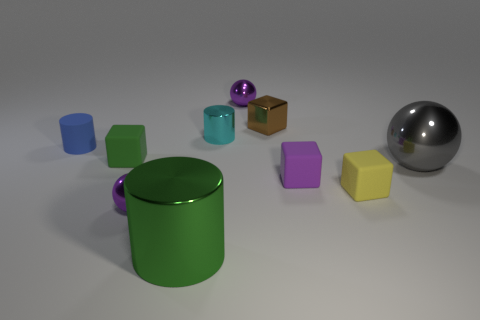Subtract all cubes. How many objects are left? 6 Add 6 small cyan things. How many small cyan things exist? 7 Subtract 0 green spheres. How many objects are left? 10 Subtract all large blue balls. Subtract all brown blocks. How many objects are left? 9 Add 7 cyan shiny cylinders. How many cyan shiny cylinders are left? 8 